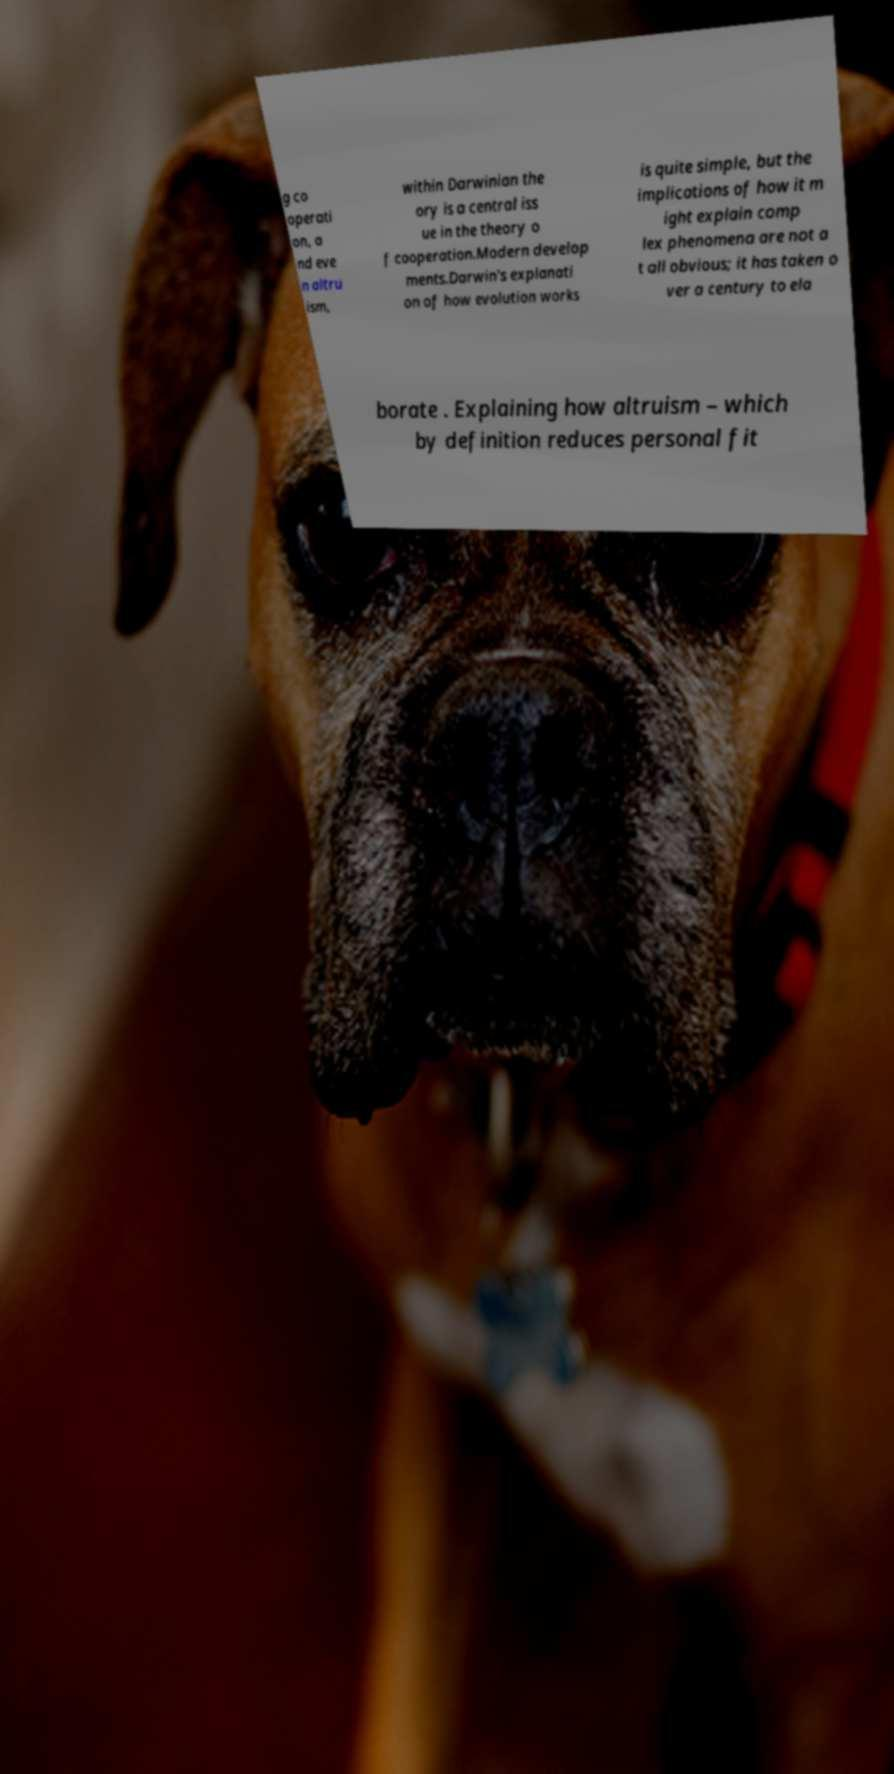Can you accurately transcribe the text from the provided image for me? g co operati on, a nd eve n altru ism, within Darwinian the ory is a central iss ue in the theory o f cooperation.Modern develop ments.Darwin's explanati on of how evolution works is quite simple, but the implications of how it m ight explain comp lex phenomena are not a t all obvious; it has taken o ver a century to ela borate . Explaining how altruism – which by definition reduces personal fit 